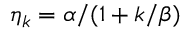<formula> <loc_0><loc_0><loc_500><loc_500>\eta _ { k } = \alpha / ( 1 + k / \beta )</formula> 